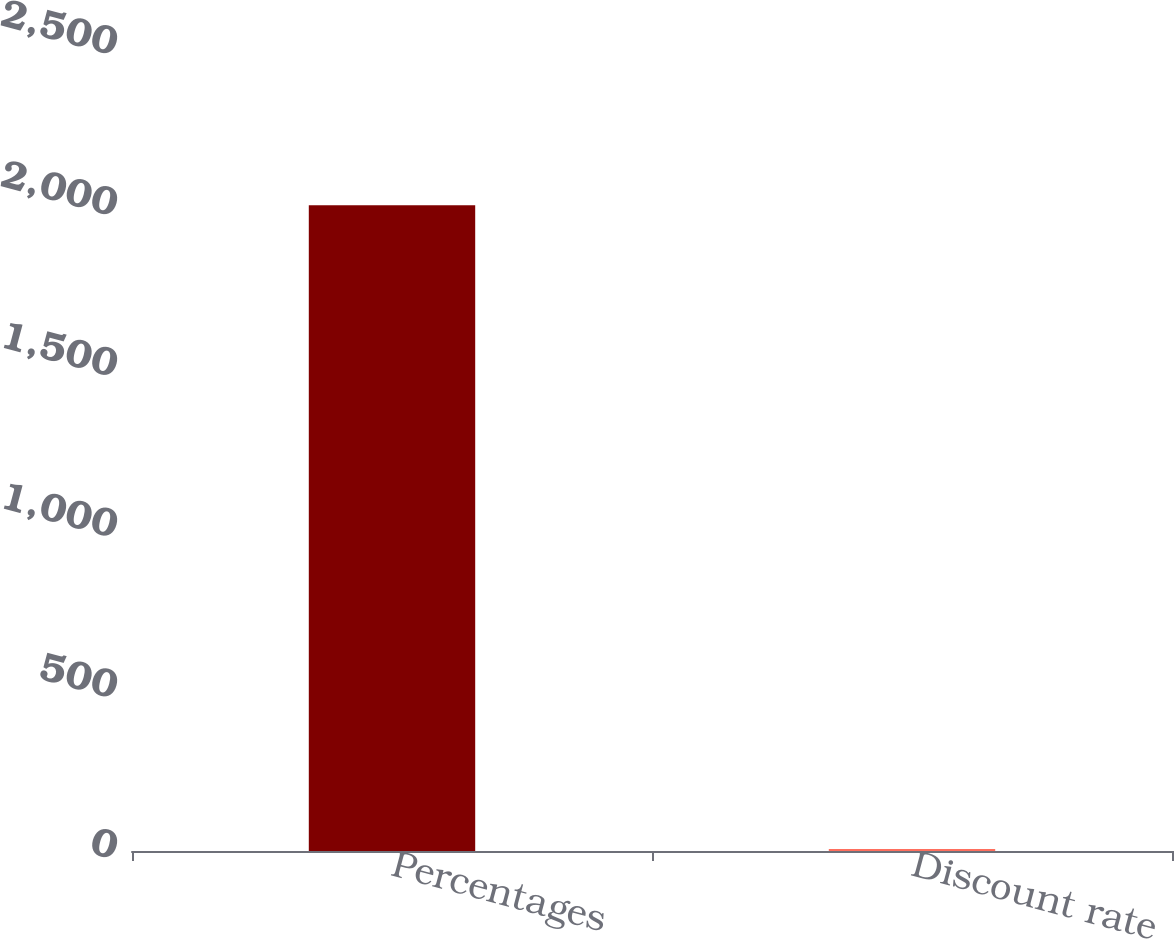<chart> <loc_0><loc_0><loc_500><loc_500><bar_chart><fcel>Percentages<fcel>Discount rate<nl><fcel>2008<fcel>6.5<nl></chart> 